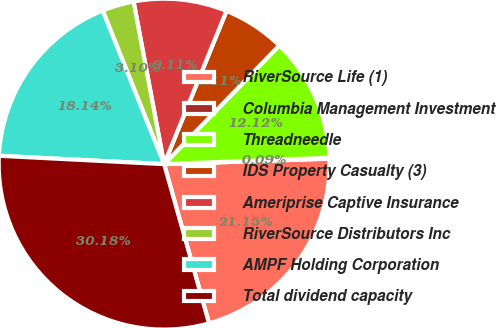Convert chart. <chart><loc_0><loc_0><loc_500><loc_500><pie_chart><fcel>RiverSource Life (1)<fcel>Columbia Management Investment<fcel>Threadneedle<fcel>IDS Property Casualty (3)<fcel>Ameriprise Captive Insurance<fcel>RiverSource Distributors Inc<fcel>AMPF Holding Corporation<fcel>Total dividend capacity<nl><fcel>21.15%<fcel>0.09%<fcel>12.12%<fcel>6.11%<fcel>9.11%<fcel>3.1%<fcel>18.14%<fcel>30.18%<nl></chart> 